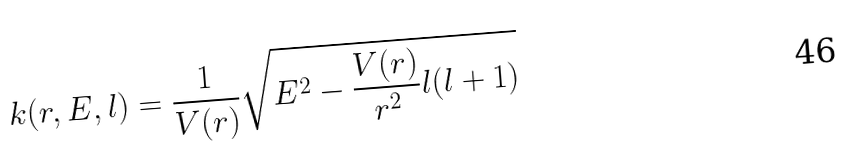<formula> <loc_0><loc_0><loc_500><loc_500>k ( r , E , l ) = \frac { 1 } { V ( r ) } \sqrt { E ^ { 2 } - \frac { V ( r ) } { r ^ { 2 } } l ( l + 1 ) }</formula> 